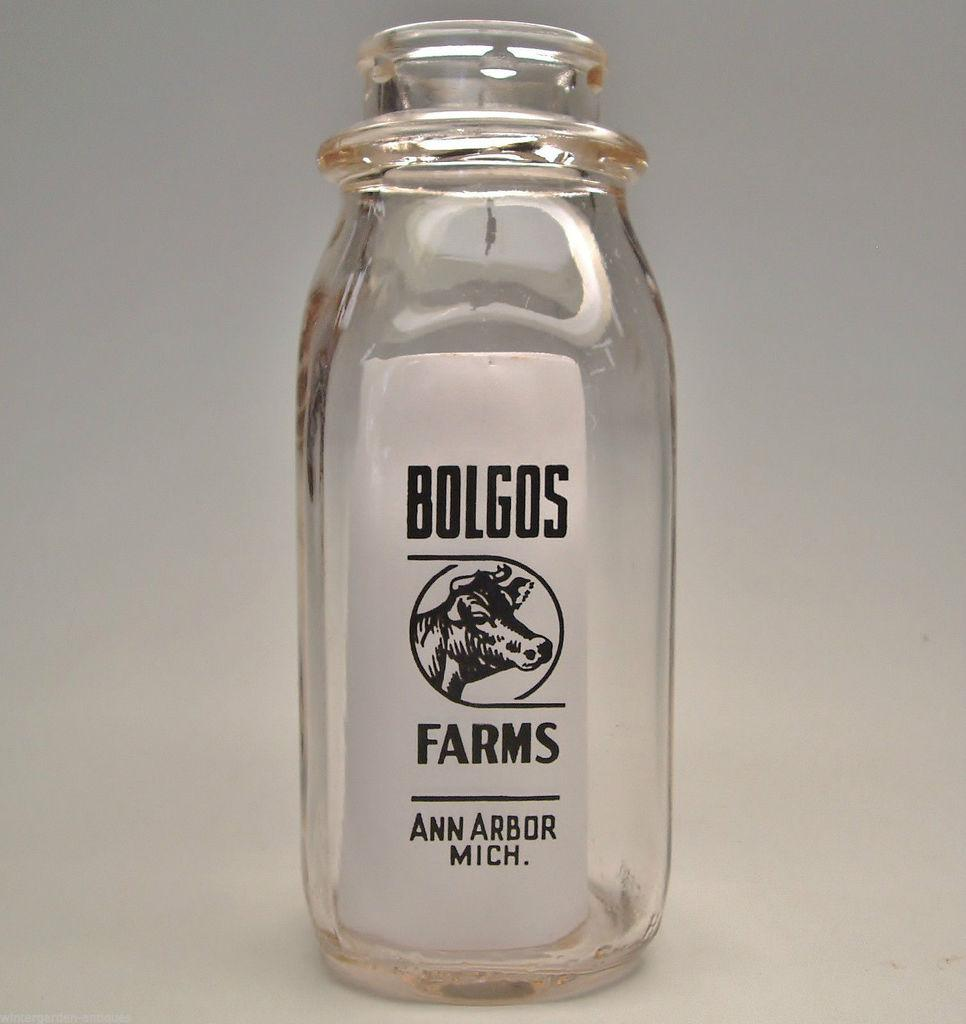<image>
Give a short and clear explanation of the subsequent image. Empty bottle with a label showing a cow for Bolgos Farms. 